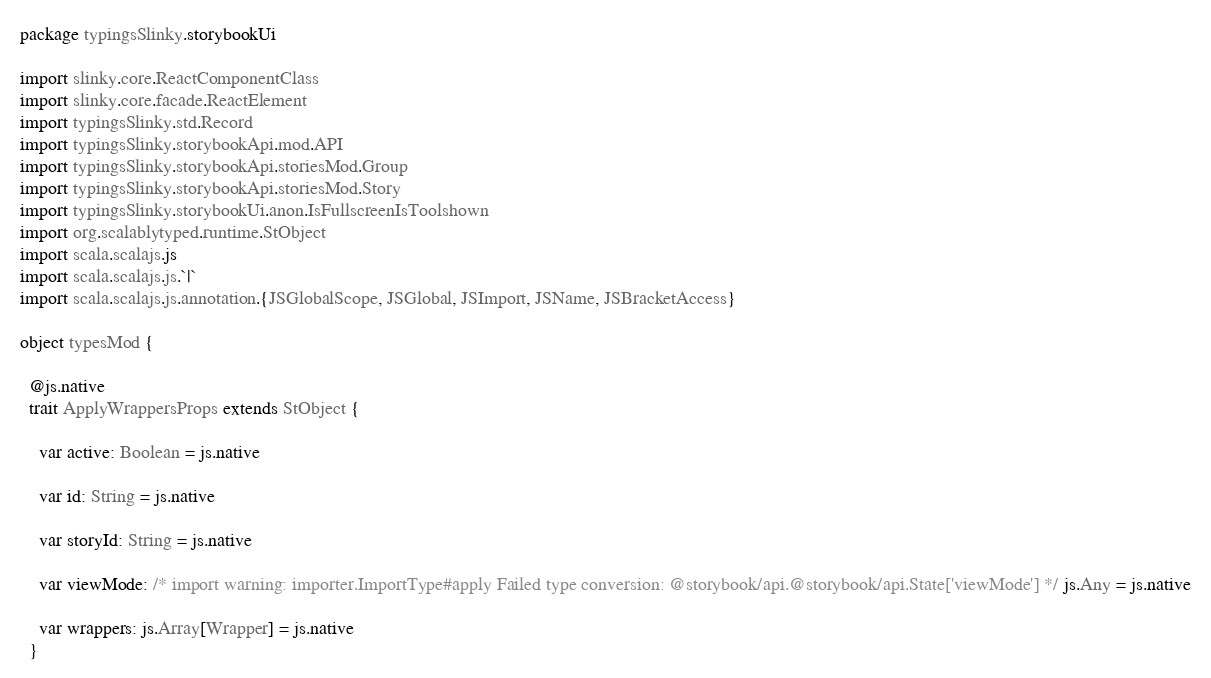Convert code to text. <code><loc_0><loc_0><loc_500><loc_500><_Scala_>package typingsSlinky.storybookUi

import slinky.core.ReactComponentClass
import slinky.core.facade.ReactElement
import typingsSlinky.std.Record
import typingsSlinky.storybookApi.mod.API
import typingsSlinky.storybookApi.storiesMod.Group
import typingsSlinky.storybookApi.storiesMod.Story
import typingsSlinky.storybookUi.anon.IsFullscreenIsToolshown
import org.scalablytyped.runtime.StObject
import scala.scalajs.js
import scala.scalajs.js.`|`
import scala.scalajs.js.annotation.{JSGlobalScope, JSGlobal, JSImport, JSName, JSBracketAccess}

object typesMod {
  
  @js.native
  trait ApplyWrappersProps extends StObject {
    
    var active: Boolean = js.native
    
    var id: String = js.native
    
    var storyId: String = js.native
    
    var viewMode: /* import warning: importer.ImportType#apply Failed type conversion: @storybook/api.@storybook/api.State['viewMode'] */ js.Any = js.native
    
    var wrappers: js.Array[Wrapper] = js.native
  }</code> 